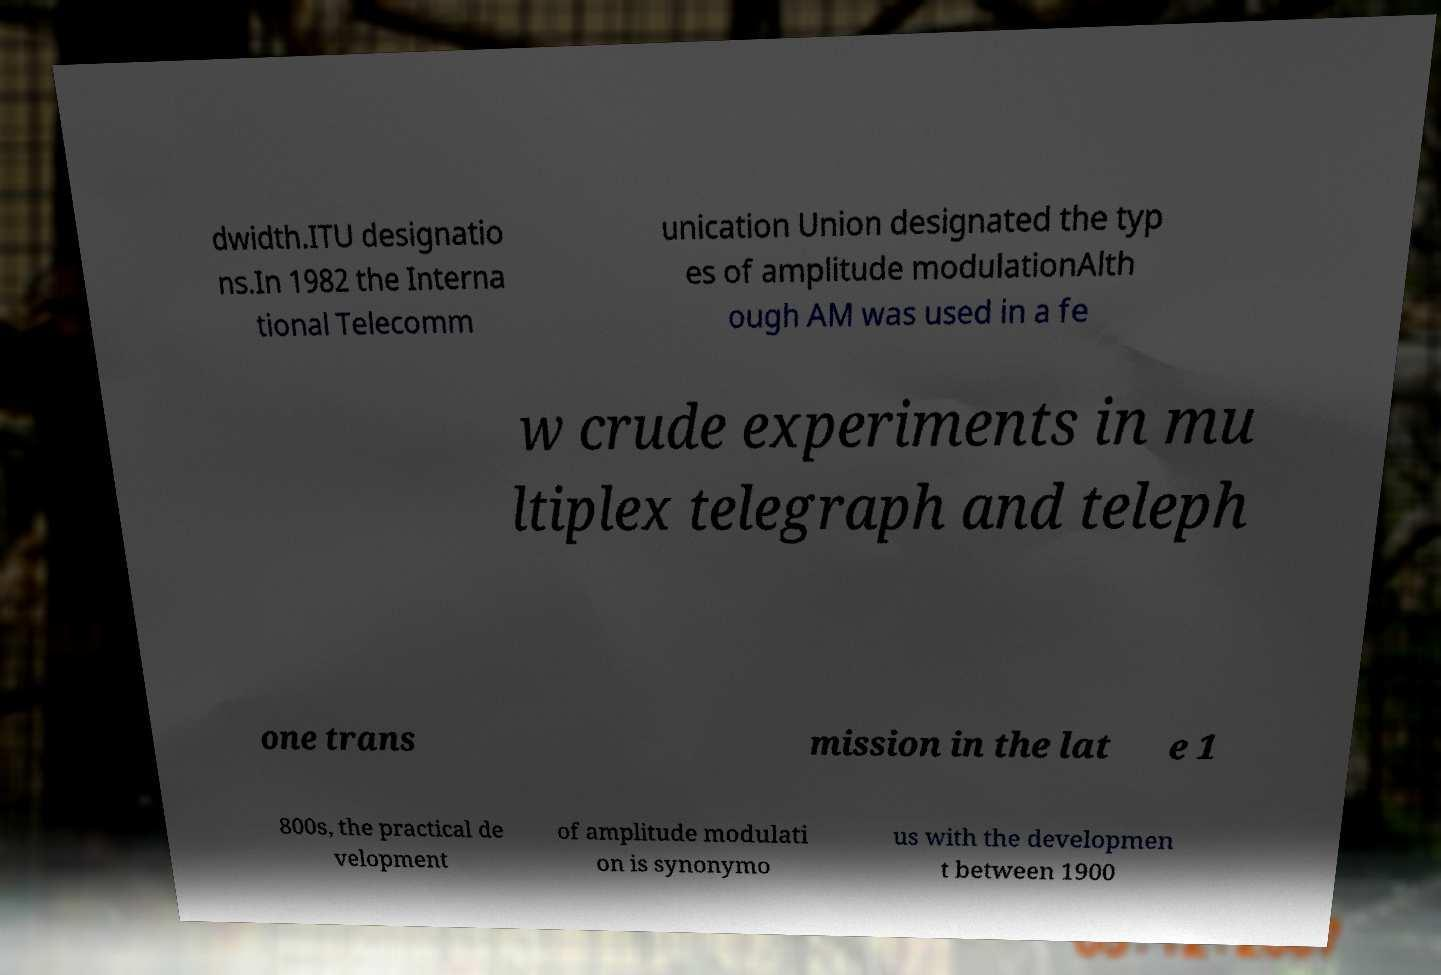Could you assist in decoding the text presented in this image and type it out clearly? dwidth.ITU designatio ns.In 1982 the Interna tional Telecomm unication Union designated the typ es of amplitude modulationAlth ough AM was used in a fe w crude experiments in mu ltiplex telegraph and teleph one trans mission in the lat e 1 800s, the practical de velopment of amplitude modulati on is synonymo us with the developmen t between 1900 